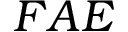<formula> <loc_0><loc_0><loc_500><loc_500>F A E</formula> 